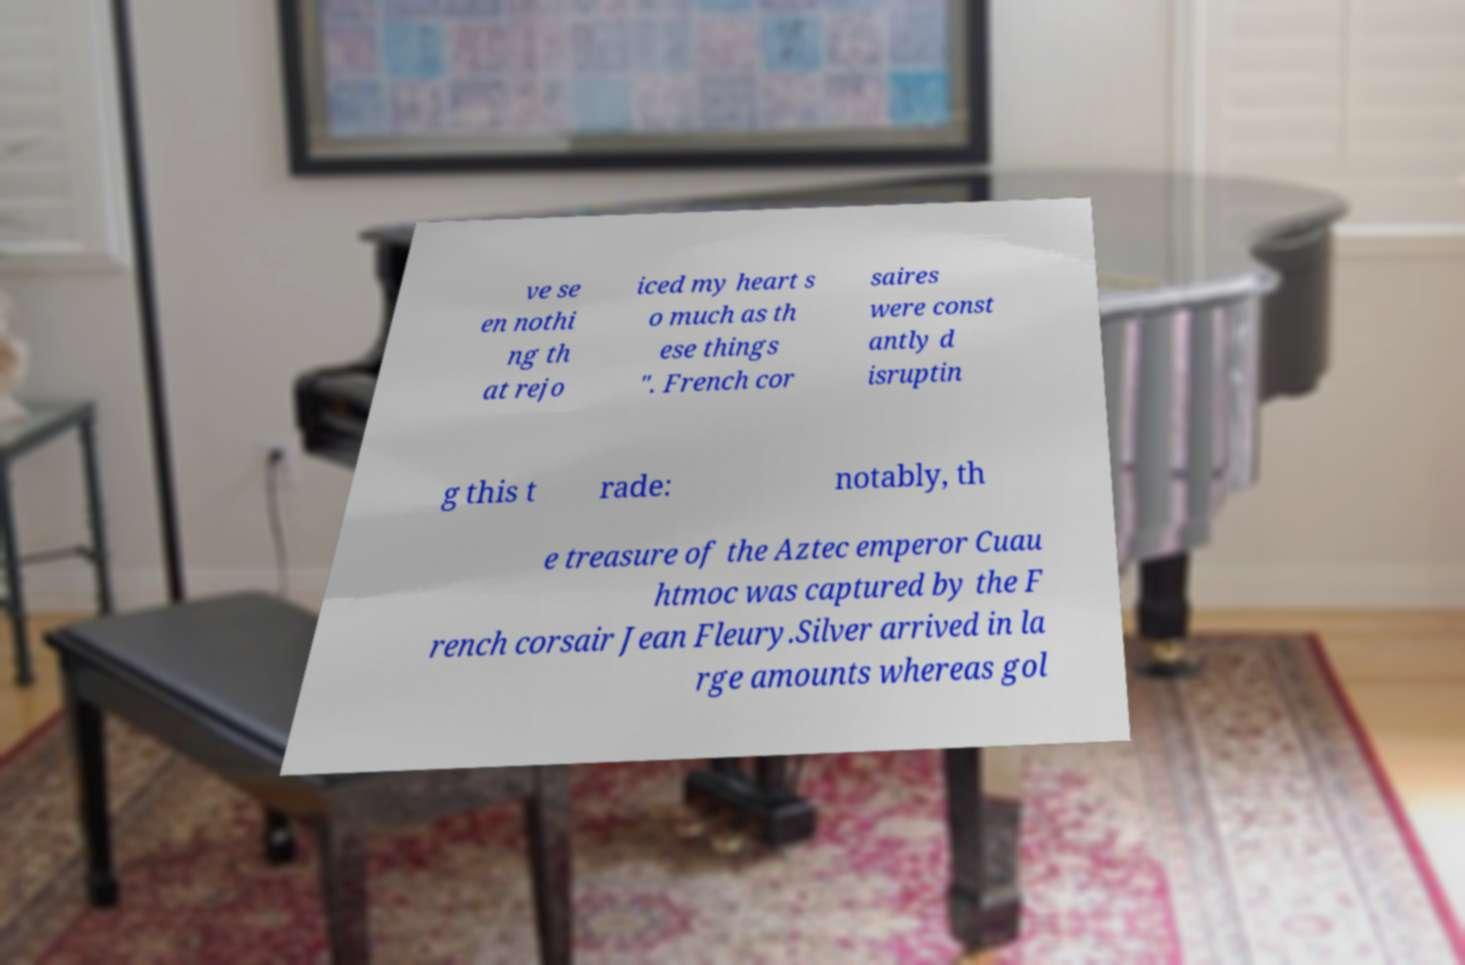Please identify and transcribe the text found in this image. ve se en nothi ng th at rejo iced my heart s o much as th ese things ". French cor saires were const antly d isruptin g this t rade: notably, th e treasure of the Aztec emperor Cuau htmoc was captured by the F rench corsair Jean Fleury.Silver arrived in la rge amounts whereas gol 